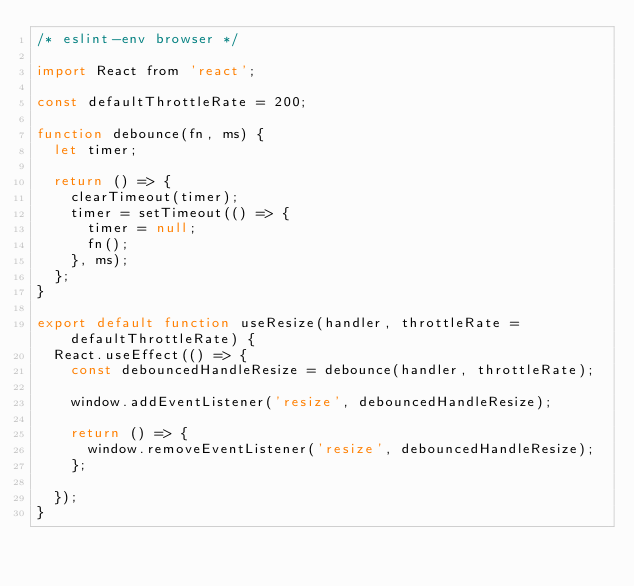<code> <loc_0><loc_0><loc_500><loc_500><_JavaScript_>/* eslint-env browser */

import React from 'react';

const defaultThrottleRate = 200;

function debounce(fn, ms) {
  let timer;

  return () => {
    clearTimeout(timer);
    timer = setTimeout(() => {
      timer = null;
      fn();
    }, ms);
  };
}

export default function useResize(handler, throttleRate = defaultThrottleRate) {
  React.useEffect(() => {
    const debouncedHandleResize = debounce(handler, throttleRate);

    window.addEventListener('resize', debouncedHandleResize);

    return () => {
      window.removeEventListener('resize', debouncedHandleResize);
    };

  });
}
</code> 